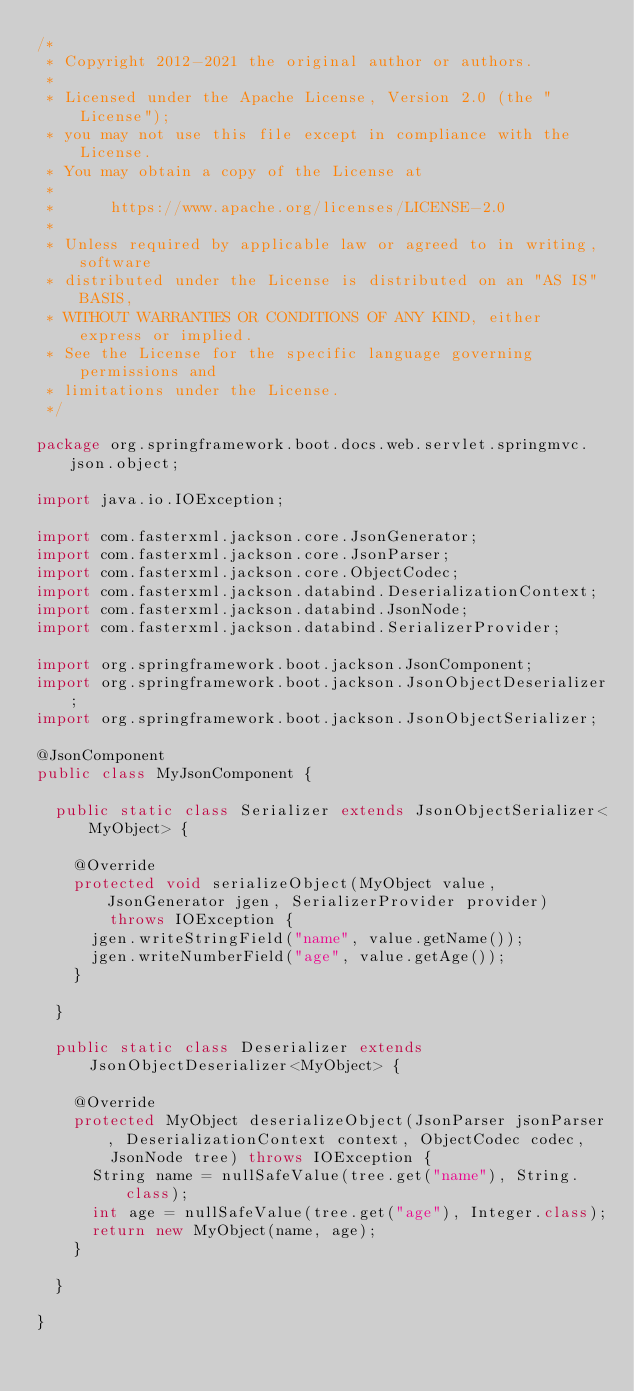Convert code to text. <code><loc_0><loc_0><loc_500><loc_500><_Java_>/*
 * Copyright 2012-2021 the original author or authors.
 *
 * Licensed under the Apache License, Version 2.0 (the "License");
 * you may not use this file except in compliance with the License.
 * You may obtain a copy of the License at
 *
 *      https://www.apache.org/licenses/LICENSE-2.0
 *
 * Unless required by applicable law or agreed to in writing, software
 * distributed under the License is distributed on an "AS IS" BASIS,
 * WITHOUT WARRANTIES OR CONDITIONS OF ANY KIND, either express or implied.
 * See the License for the specific language governing permissions and
 * limitations under the License.
 */

package org.springframework.boot.docs.web.servlet.springmvc.json.object;

import java.io.IOException;

import com.fasterxml.jackson.core.JsonGenerator;
import com.fasterxml.jackson.core.JsonParser;
import com.fasterxml.jackson.core.ObjectCodec;
import com.fasterxml.jackson.databind.DeserializationContext;
import com.fasterxml.jackson.databind.JsonNode;
import com.fasterxml.jackson.databind.SerializerProvider;

import org.springframework.boot.jackson.JsonComponent;
import org.springframework.boot.jackson.JsonObjectDeserializer;
import org.springframework.boot.jackson.JsonObjectSerializer;

@JsonComponent
public class MyJsonComponent {

	public static class Serializer extends JsonObjectSerializer<MyObject> {

		@Override
		protected void serializeObject(MyObject value, JsonGenerator jgen, SerializerProvider provider)
				throws IOException {
			jgen.writeStringField("name", value.getName());
			jgen.writeNumberField("age", value.getAge());
		}

	}

	public static class Deserializer extends JsonObjectDeserializer<MyObject> {

		@Override
		protected MyObject deserializeObject(JsonParser jsonParser, DeserializationContext context, ObjectCodec codec,
				JsonNode tree) throws IOException {
			String name = nullSafeValue(tree.get("name"), String.class);
			int age = nullSafeValue(tree.get("age"), Integer.class);
			return new MyObject(name, age);
		}

	}

}
</code> 